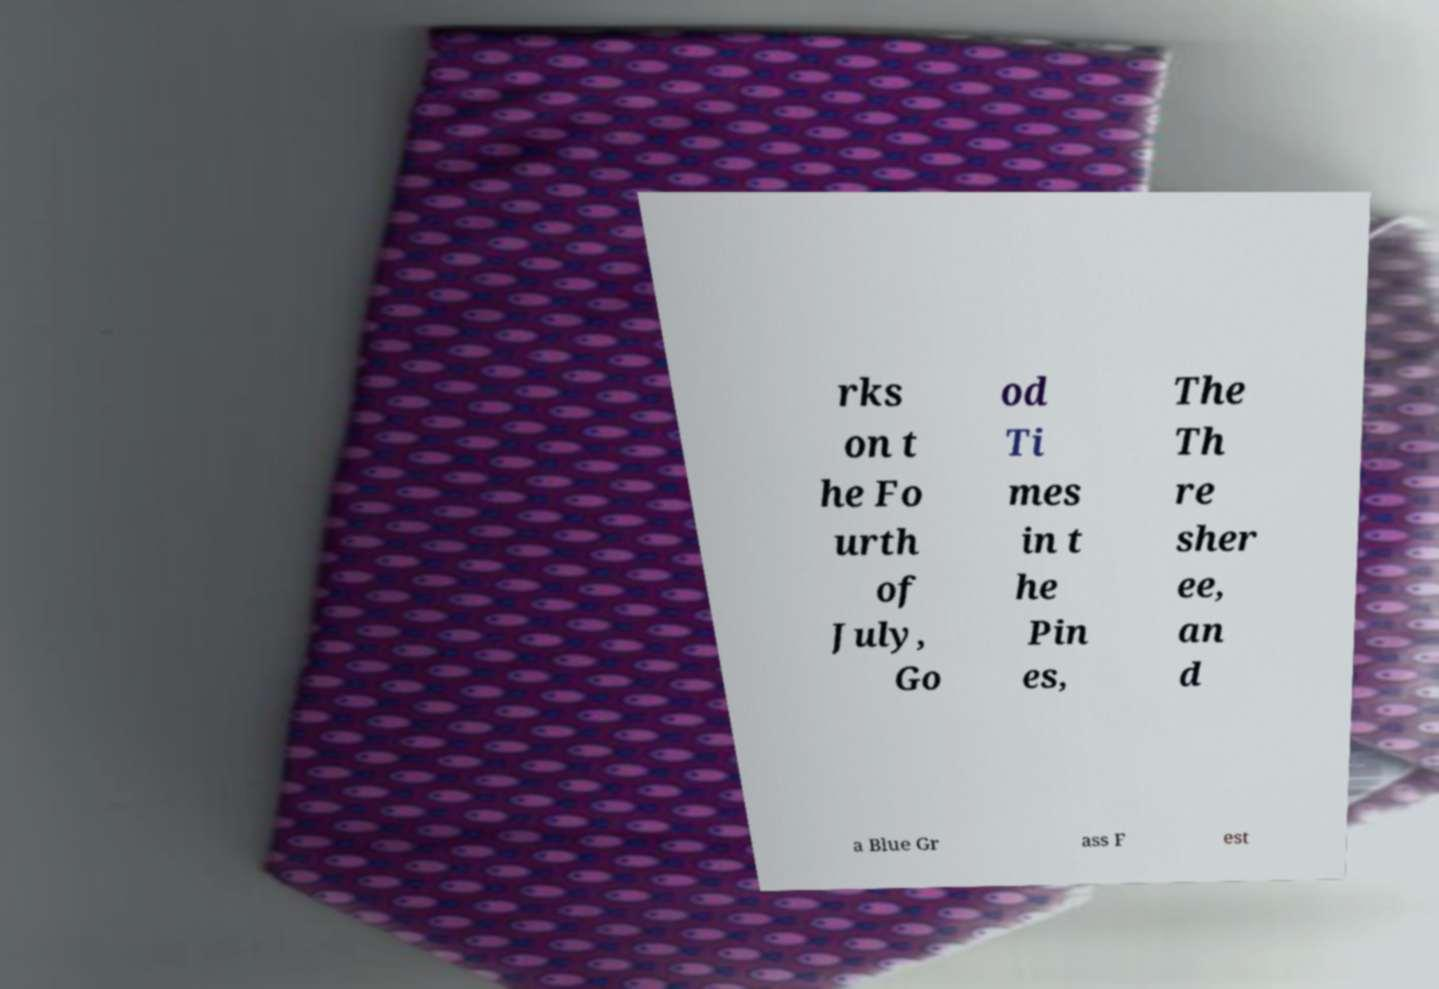For documentation purposes, I need the text within this image transcribed. Could you provide that? rks on t he Fo urth of July, Go od Ti mes in t he Pin es, The Th re sher ee, an d a Blue Gr ass F est 